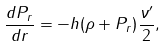Convert formula to latex. <formula><loc_0><loc_0><loc_500><loc_500>\frac { d P _ { r } } { d r } = - h ( \rho + P _ { r } ) \frac { \nu ^ { \prime } } { 2 } ,</formula> 